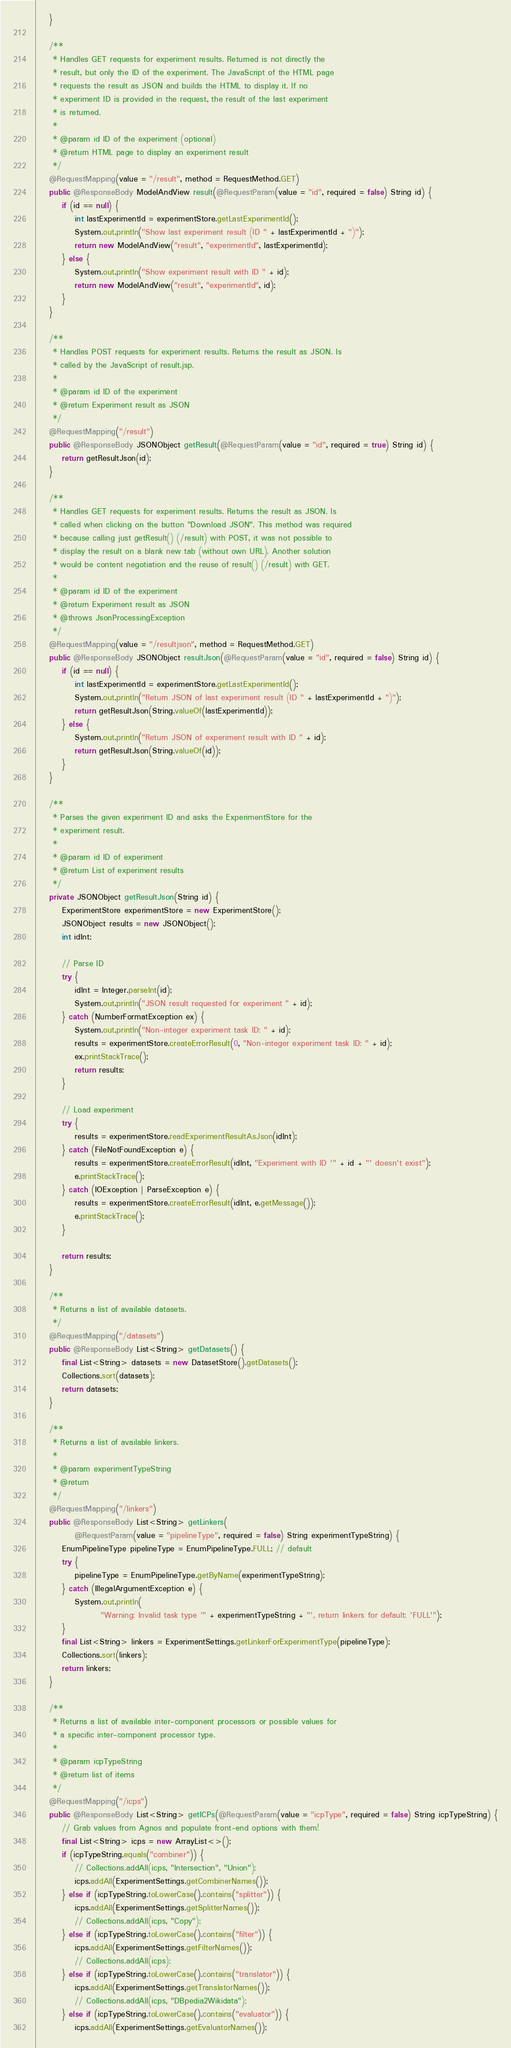<code> <loc_0><loc_0><loc_500><loc_500><_Java_>	}

	/**
	 * Handles GET requests for experiment results. Returned is not directly the
	 * result, but only the ID of the experiment. The JavaScript of the HTML page
	 * requests the result as JSON and builds the HTML to display it. If no
	 * experiment ID is provided in the request, the result of the last experiment
	 * is returned.
	 * 
	 * @param id ID of the experiment (optional)
	 * @return HTML page to display an experiment result
	 */
	@RequestMapping(value = "/result", method = RequestMethod.GET)
	public @ResponseBody ModelAndView result(@RequestParam(value = "id", required = false) String id) {
		if (id == null) {
			int lastExperimentId = experimentStore.getLastExperimentId();
			System.out.println("Show last experiment result (ID " + lastExperimentId + ")");
			return new ModelAndView("result", "experimentId", lastExperimentId);
		} else {
			System.out.println("Show experiment result with ID " + id);
			return new ModelAndView("result", "experimentId", id);
		}
	}

	/**
	 * Handles POST requests for experiment results. Returns the result as JSON. Is
	 * called by the JavaScript of result.jsp.
	 * 
	 * @param id ID of the experiment
	 * @return Experiment result as JSON
	 */
	@RequestMapping("/result")
	public @ResponseBody JSONObject getResult(@RequestParam(value = "id", required = true) String id) {
		return getResultJson(id);
	}

	/**
	 * Handles GET requests for experiment results. Returns the result as JSON. Is
	 * called when clicking on the button "Download JSON". This method was required
	 * because calling just getResult() (/result) with POST, it was not possible to
	 * display the result on a blank new tab (without own URL). Another solution
	 * would be content negotiation and the reuse of result() (/result) with GET.
	 * 
	 * @param id ID of the experiment
	 * @return Experiment result as JSON
	 * @throws JsonProcessingException
	 */
	@RequestMapping(value = "/resultjson", method = RequestMethod.GET)
	public @ResponseBody JSONObject resultJson(@RequestParam(value = "id", required = false) String id) {
		if (id == null) {
			int lastExperimentId = experimentStore.getLastExperimentId();
			System.out.println("Return JSON of last experiment result (ID " + lastExperimentId + ")");
			return getResultJson(String.valueOf(lastExperimentId));
		} else {
			System.out.println("Return JSON of experiment result with ID " + id);
			return getResultJson(String.valueOf(id));
		}
	}

	/**
	 * Parses the given experiment ID and asks the ExperimentStore for the
	 * experiment result.
	 * 
	 * @param id ID of experiment
	 * @return List of experiment results
	 */
	private JSONObject getResultJson(String id) {
		ExperimentStore experimentStore = new ExperimentStore();
		JSONObject results = new JSONObject();
		int idInt;

		// Parse ID
		try {
			idInt = Integer.parseInt(id);
			System.out.println("JSON result requested for experiment " + id);
		} catch (NumberFormatException ex) {
			System.out.println("Non-integer experiment task ID: " + id);
			results = experimentStore.createErrorResult(0, "Non-integer experiment task ID: " + id);
			ex.printStackTrace();
			return results;
		}

		// Load experiment
		try {
			results = experimentStore.readExperimentResultAsJson(idInt);
		} catch (FileNotFoundException e) {
			results = experimentStore.createErrorResult(idInt, "Experiment with ID '" + id + "' doesn't exist");
			e.printStackTrace();
		} catch (IOException | ParseException e) {
			results = experimentStore.createErrorResult(idInt, e.getMessage());
			e.printStackTrace();
		}

		return results;
	}

	/**
	 * Returns a list of available datasets.
	 */
	@RequestMapping("/datasets")
	public @ResponseBody List<String> getDatasets() {
		final List<String> datasets = new DatasetStore().getDatasets();
		Collections.sort(datasets);
		return datasets;
	}

	/**
	 * Returns a list of available linkers.
	 * 
	 * @param experimentTypeString
	 * @return
	 */
	@RequestMapping("/linkers")
	public @ResponseBody List<String> getLinkers(
			@RequestParam(value = "pipelineType", required = false) String experimentTypeString) {
		EnumPipelineType pipelineType = EnumPipelineType.FULL; // default
		try {
			pipelineType = EnumPipelineType.getByName(experimentTypeString);
		} catch (IllegalArgumentException e) {
			System.out.println(
					"Warning: Invalid task type '" + experimentTypeString + "', return linkers for default: 'FULL'");
		}
		final List<String> linkers = ExperimentSettings.getLinkerForExperimentType(pipelineType);
		Collections.sort(linkers);
		return linkers;
	}

	/**
	 * Returns a list of available inter-component processors or possible values for
	 * a specific inter-component processor type.
	 * 
	 * @param icpTypeString
	 * @return list of items
	 */
	@RequestMapping("/icps")
	public @ResponseBody List<String> getICPs(@RequestParam(value = "icpType", required = false) String icpTypeString) {
		// Grab values from Agnos and populate front-end options with them!
		final List<String> icps = new ArrayList<>();
		if (icpTypeString.equals("combiner")) {
			// Collections.addAll(icps, "Intersection", "Union");
			icps.addAll(ExperimentSettings.getCombinerNames());
		} else if (icpTypeString.toLowerCase().contains("splitter")) {
			icps.addAll(ExperimentSettings.getSplitterNames());
			// Collections.addAll(icps, "Copy");
		} else if (icpTypeString.toLowerCase().contains("filter")) {
			icps.addAll(ExperimentSettings.getFilterNames());
			// Collections.addAll(icps);
		} else if (icpTypeString.toLowerCase().contains("translator")) {
			icps.addAll(ExperimentSettings.getTranslatorNames());
			// Collections.addAll(icps, "DBpedia2Wikidata");
		} else if (icpTypeString.toLowerCase().contains("evaluator")) {
			icps.addAll(ExperimentSettings.getEvaluatorNames());</code> 